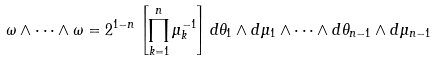Convert formula to latex. <formula><loc_0><loc_0><loc_500><loc_500>\omega \wedge \cdots \wedge \omega & = 2 ^ { 1 - n } \left [ \prod _ { k = 1 } ^ { n } \mu _ { k } ^ { - 1 } \right ] d \theta _ { 1 } \wedge d \mu _ { 1 } \wedge \cdots \wedge d \theta _ { n - 1 } \wedge d \mu _ { n - 1 }</formula> 